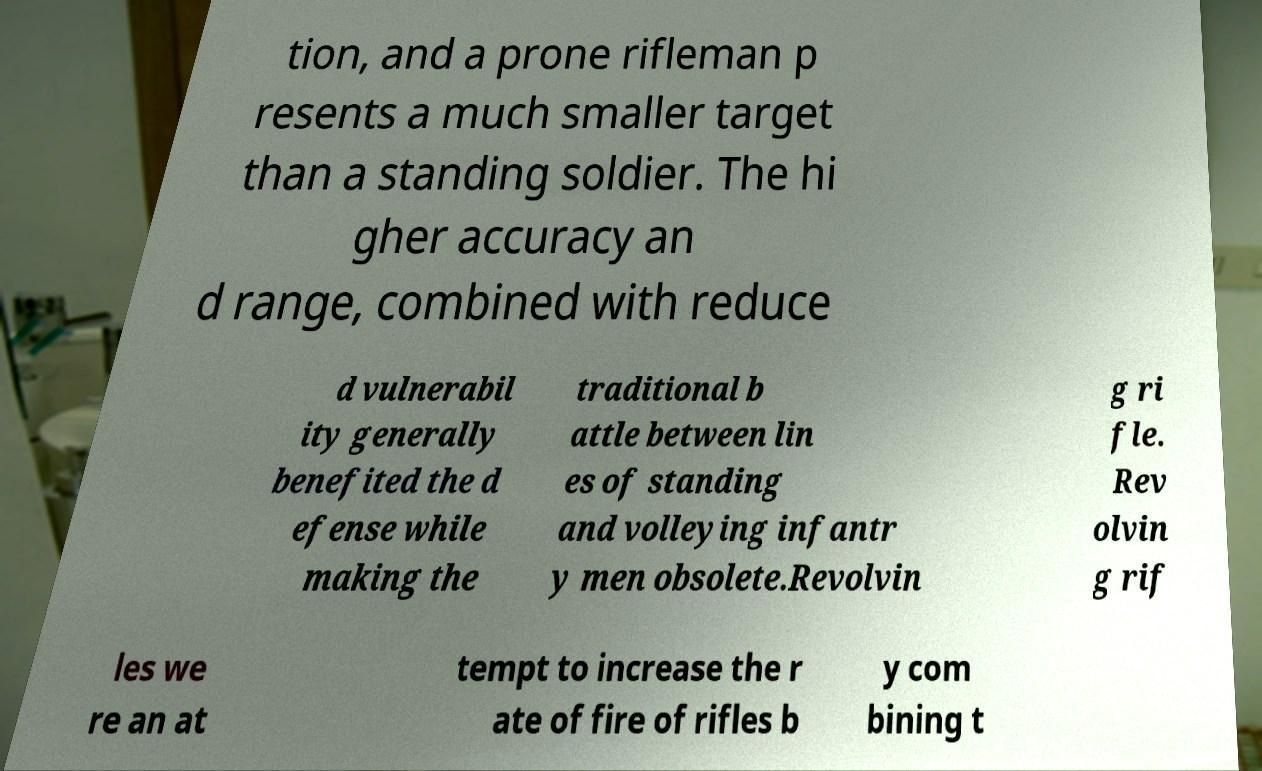I need the written content from this picture converted into text. Can you do that? tion, and a prone rifleman p resents a much smaller target than a standing soldier. The hi gher accuracy an d range, combined with reduce d vulnerabil ity generally benefited the d efense while making the traditional b attle between lin es of standing and volleying infantr y men obsolete.Revolvin g ri fle. Rev olvin g rif les we re an at tempt to increase the r ate of fire of rifles b y com bining t 